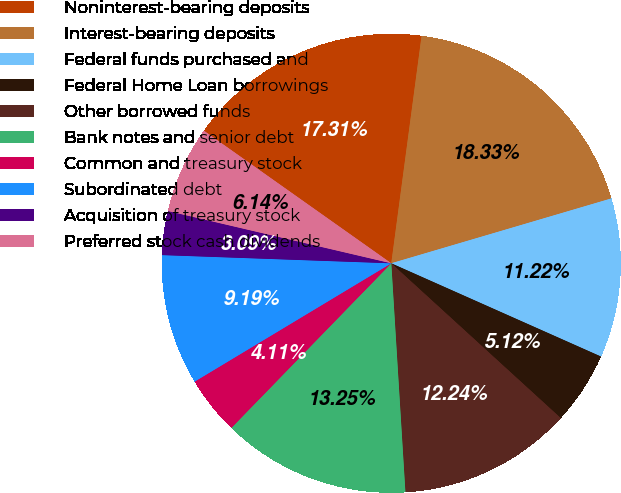Convert chart. <chart><loc_0><loc_0><loc_500><loc_500><pie_chart><fcel>Noninterest-bearing deposits<fcel>Interest-bearing deposits<fcel>Federal funds purchased and<fcel>Federal Home Loan borrowings<fcel>Other borrowed funds<fcel>Bank notes and senior debt<fcel>Common and treasury stock<fcel>Subordinated debt<fcel>Acquisition of treasury stock<fcel>Preferred stock cash dividends<nl><fcel>17.31%<fcel>18.33%<fcel>11.22%<fcel>5.12%<fcel>12.24%<fcel>13.25%<fcel>4.11%<fcel>9.19%<fcel>3.09%<fcel>6.14%<nl></chart> 